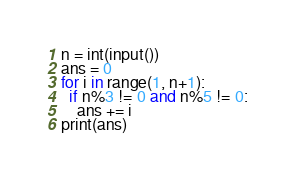Convert code to text. <code><loc_0><loc_0><loc_500><loc_500><_Python_>n = int(input())
ans = 0
for i in range(1, n+1):
  if n%3 != 0 and n%5 != 0:
  	ans += i
print(ans)</code> 